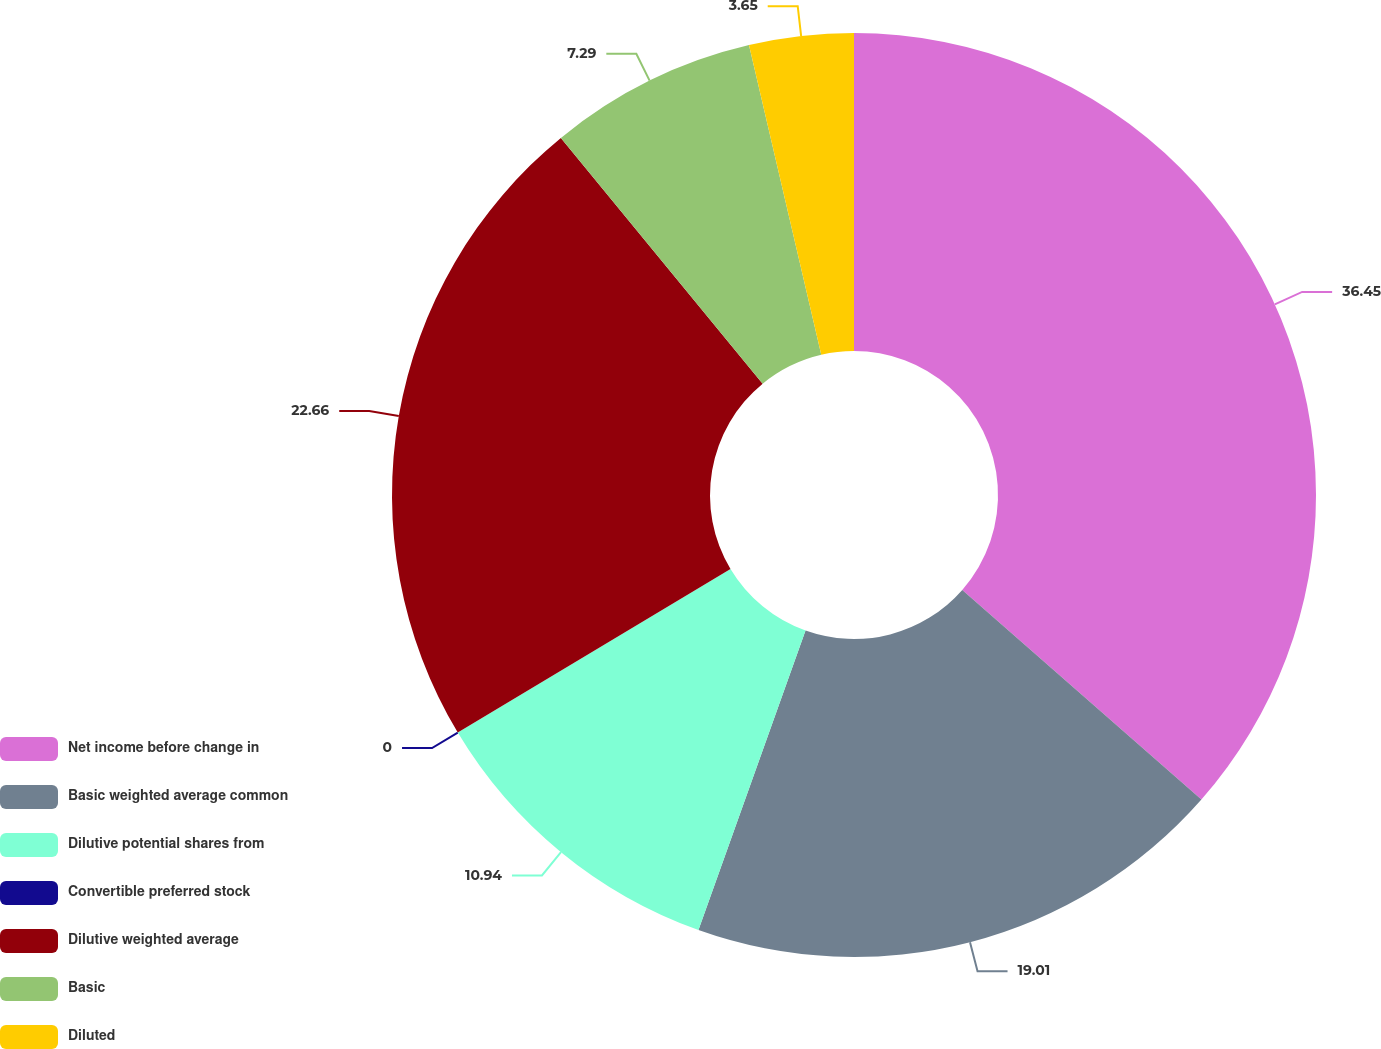Convert chart. <chart><loc_0><loc_0><loc_500><loc_500><pie_chart><fcel>Net income before change in<fcel>Basic weighted average common<fcel>Dilutive potential shares from<fcel>Convertible preferred stock<fcel>Dilutive weighted average<fcel>Basic<fcel>Diluted<nl><fcel>36.46%<fcel>19.01%<fcel>10.94%<fcel>0.0%<fcel>22.66%<fcel>7.29%<fcel>3.65%<nl></chart> 